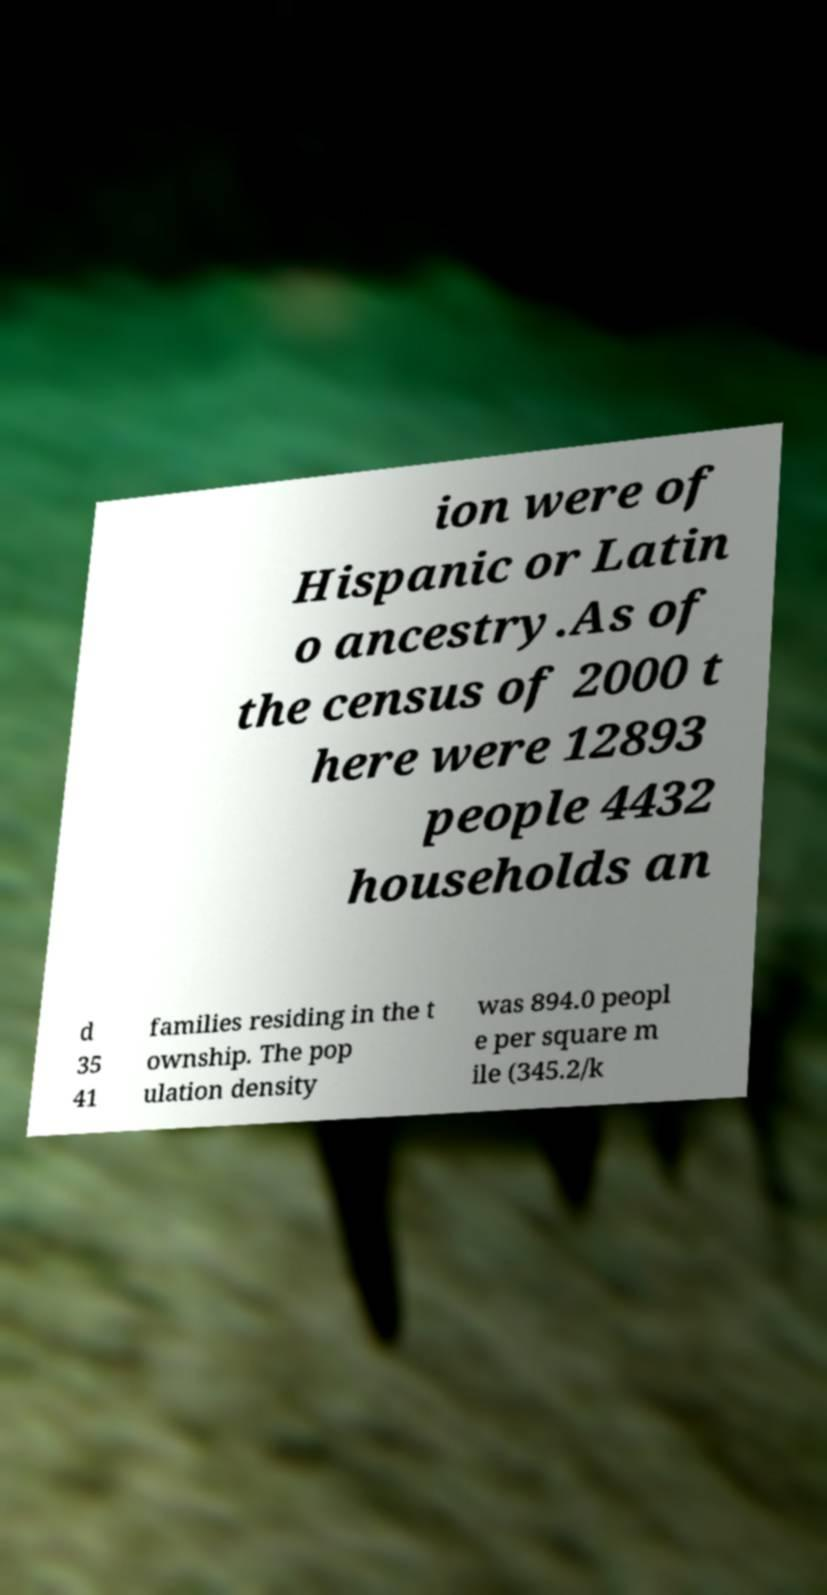For documentation purposes, I need the text within this image transcribed. Could you provide that? ion were of Hispanic or Latin o ancestry.As of the census of 2000 t here were 12893 people 4432 households an d 35 41 families residing in the t ownship. The pop ulation density was 894.0 peopl e per square m ile (345.2/k 